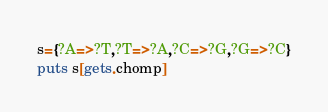<code> <loc_0><loc_0><loc_500><loc_500><_Ruby_>s={?A=>?T,?T=>?A,?C=>?G,?G=>?C}
puts s[gets.chomp]</code> 